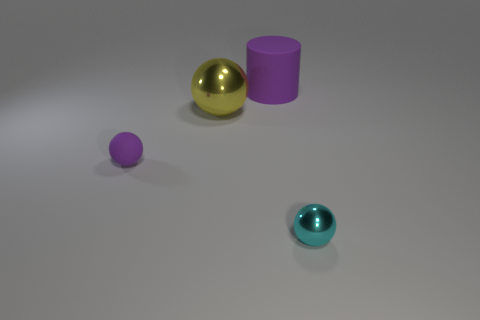The purple matte thing that is behind the big yellow sphere has what shape? The purple matte object positioned behind the large yellow sphere appears to be cylindrical in shape. It's characterized by its straight sides and circular base, a typical geometric form for a cylinder. 